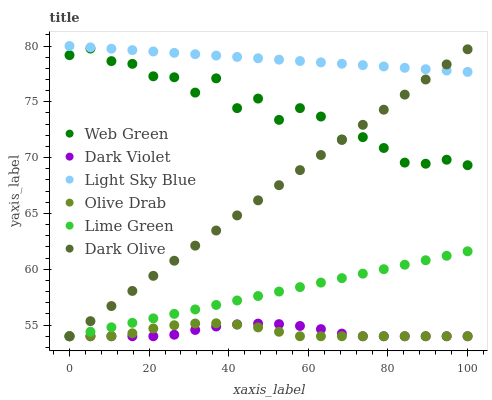Does Olive Drab have the minimum area under the curve?
Answer yes or no. Yes. Does Light Sky Blue have the maximum area under the curve?
Answer yes or no. Yes. Does Dark Violet have the minimum area under the curve?
Answer yes or no. No. Does Dark Violet have the maximum area under the curve?
Answer yes or no. No. Is Lime Green the smoothest?
Answer yes or no. Yes. Is Web Green the roughest?
Answer yes or no. Yes. Is Dark Violet the smoothest?
Answer yes or no. No. Is Dark Violet the roughest?
Answer yes or no. No. Does Dark Olive have the lowest value?
Answer yes or no. Yes. Does Light Sky Blue have the lowest value?
Answer yes or no. No. Does Light Sky Blue have the highest value?
Answer yes or no. Yes. Does Dark Violet have the highest value?
Answer yes or no. No. Is Dark Violet less than Web Green?
Answer yes or no. Yes. Is Web Green greater than Lime Green?
Answer yes or no. Yes. Does Dark Olive intersect Light Sky Blue?
Answer yes or no. Yes. Is Dark Olive less than Light Sky Blue?
Answer yes or no. No. Is Dark Olive greater than Light Sky Blue?
Answer yes or no. No. Does Dark Violet intersect Web Green?
Answer yes or no. No. 